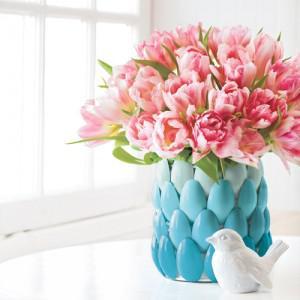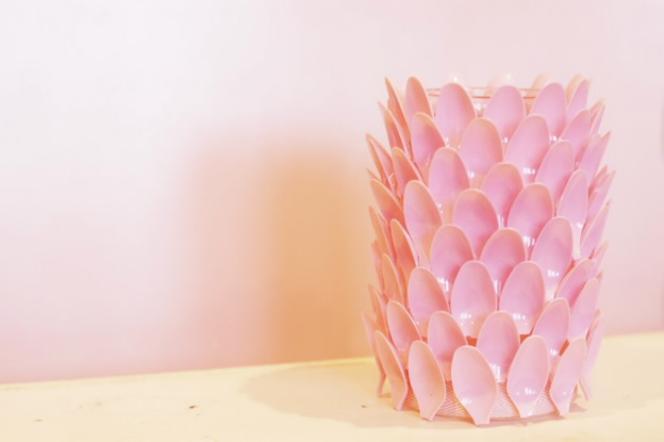The first image is the image on the left, the second image is the image on the right. Assess this claim about the two images: "Every container is either white or clear". Correct or not? Answer yes or no. No. The first image is the image on the left, the second image is the image on the right. For the images shown, is this caption "Some of the vases are see-thru; you can see the stems through the vase walls." true? Answer yes or no. No. 